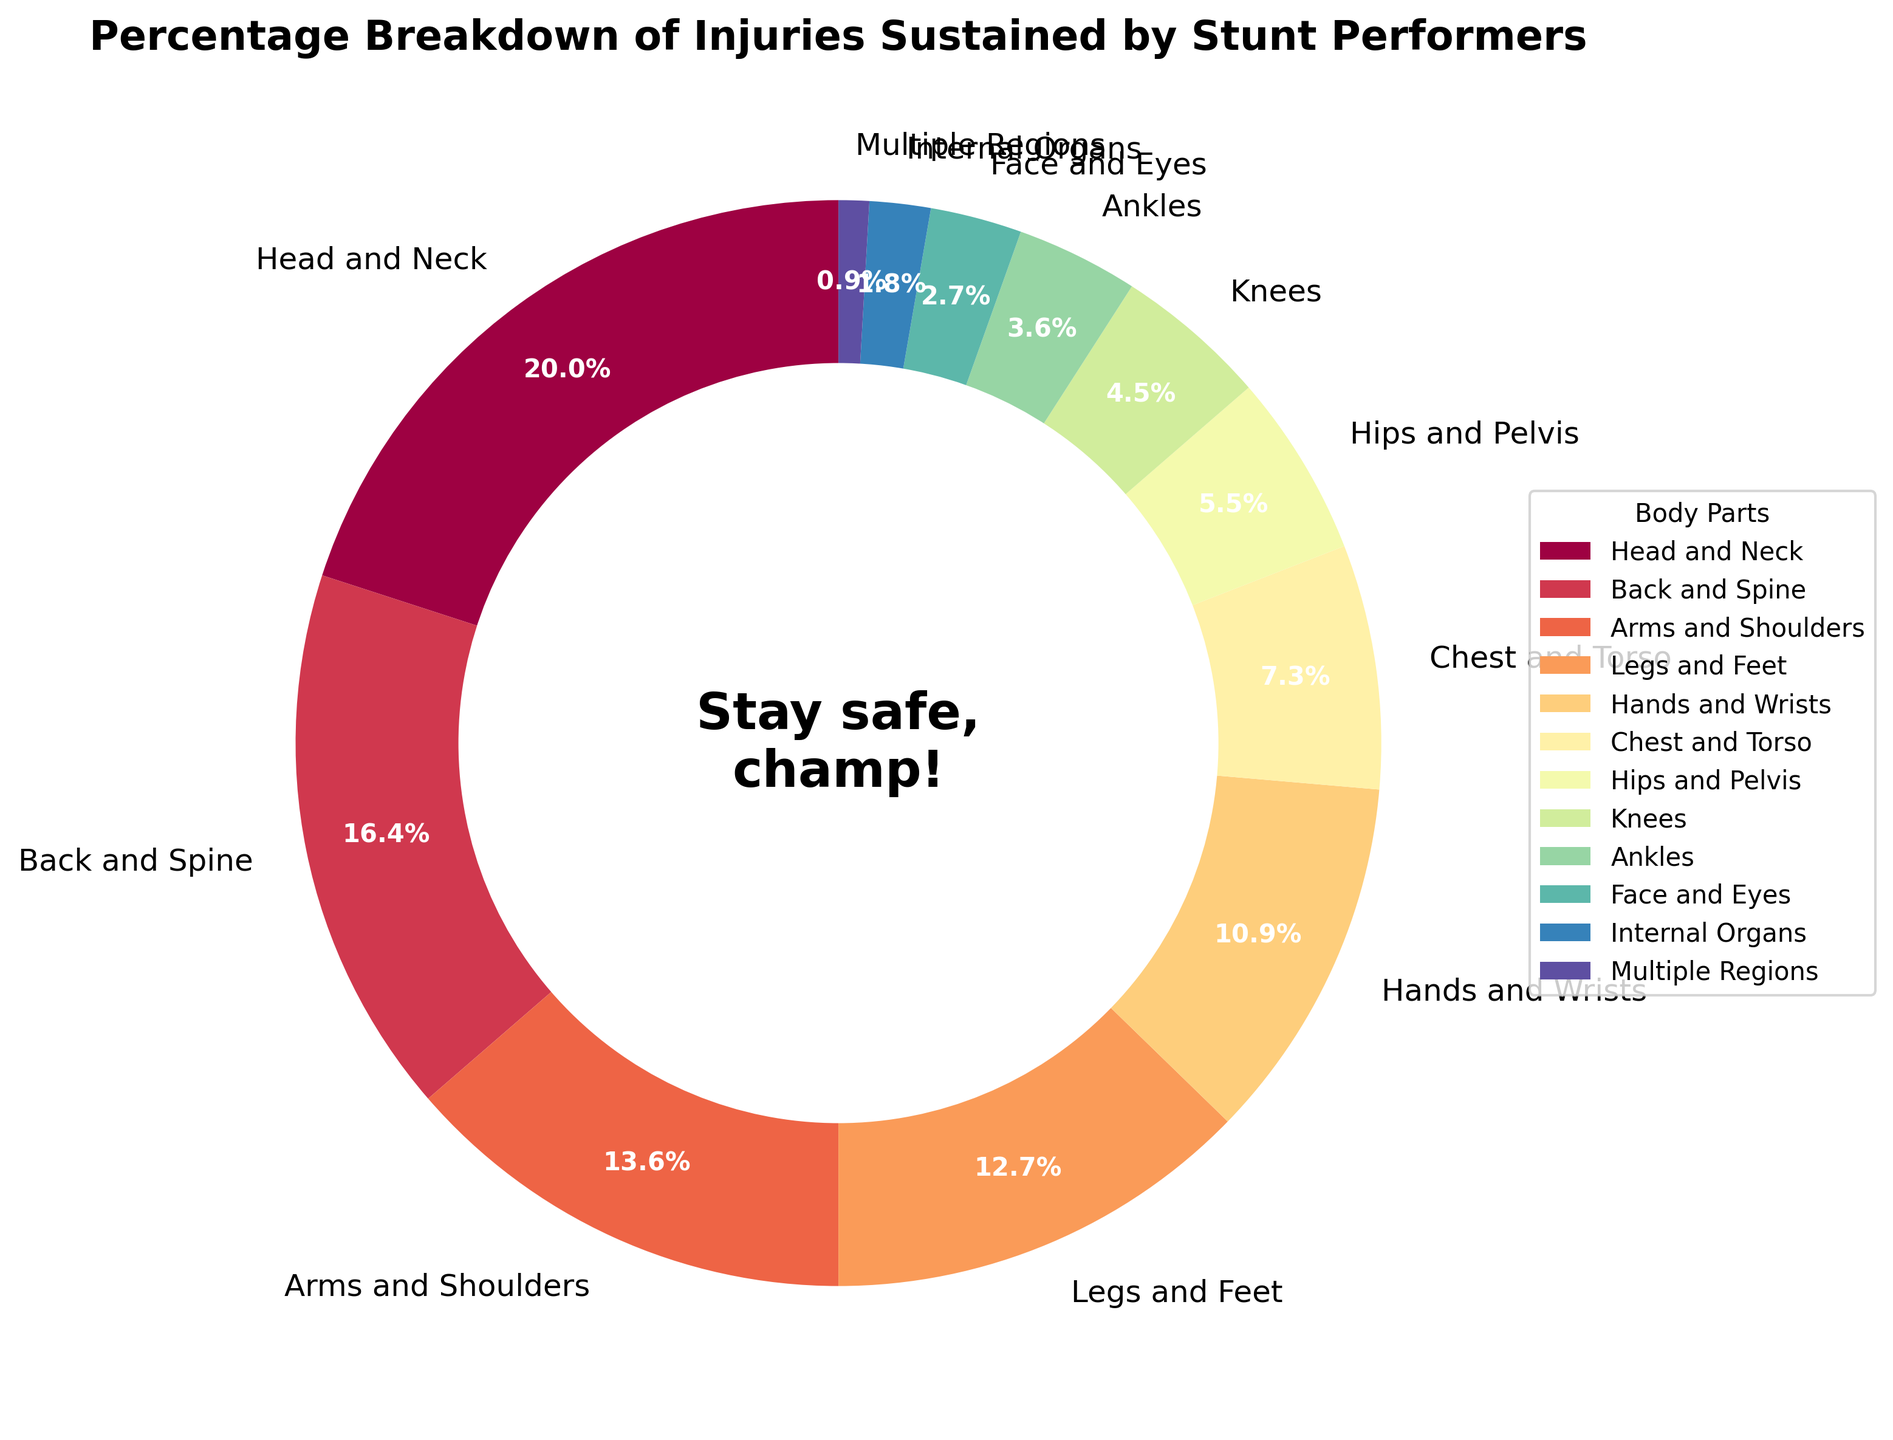What percentage of injuries are related to the Head and Neck? To find the percentage of injuries related to the Head and Neck, we look at the labeled section of the pie chart corresponding to "Head and Neck". The percentage is clearly indicated within the slice.
Answer: 22% Which body part has the lowest percentage of injuries? To determine the body part with the lowest percentage of injuries, we scan through the slices and their corresponding labels. The smallest percentage label will indicate the answer.
Answer: Multiple Regions What is the combined percentage of injuries for the Arms and Shoulders, and Legs and Feet? We add the percentage values for Arms and Shoulders (15%) and Legs and Feet (14%).
Answer: 29% Is the percentage of injuries to the Chest and Torso greater than the percentage of injuries to the Hands and Wrists? We compare the percentage values for Chest and Torso (8%) and Hands and Wrists (12%). We observe that 8% is less than 12%.
Answer: No Which body parts collectively account for more than 50% of the injuries? We identify and sum the percentages of the most significant contributing body parts until the total surpasses 50%. Head and Neck (22%), Back and Spine (18%), Arms and Shoulders (15%) add up to 55%, covering more than half of the injuries.
Answer: Head and Neck, Back and Spine, Arms and Shoulders What is the visual color scheme used for depicting injuries among different body parts? The color scheme appears as distinct shades or hues for each body part slice in the pie chart, creating visual separation and clarity. Multiple colors represented using a spectrum.
Answer: Multiple colors/spectrum How much higher is the percentage of injuries to the Back and Spine compared to the Internal Organs? We subtract the percentage for Internal Organs (2%) from the percentage for Back and Spine (18%).
Answer: 16% If the Head and Neck injuries were reduced by half, what percentage would they represent? Halving the Head and Neck injury percentage (22%), we calculate 22% / 2 = 11%.
Answer: 11% What is the total percentage of injuries to body parts located on the lower half of the body (Legs and Feet, Knees, Ankles, Hips and Pelvis)? We sum the percentages for Legs and Feet (14%), Knees (5%), Ankles (4%), and Hips and Pelvis (6%).
Answer: 29% Which body part(s) include injuries by less than 10%? By inspecting the pie chart segments with percentages below 10%, identifying the corresponding body parts: Chest and Torso, Hips and Pelvis, Knees, Ankles, Face and Eyes, Internal Organs, and Multiple Regions.
Answer: Six body parts 